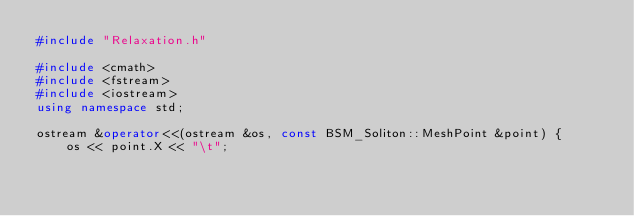Convert code to text. <code><loc_0><loc_0><loc_500><loc_500><_C++_>#include "Relaxation.h"

#include <cmath>
#include <fstream>
#include <iostream>
using namespace std;

ostream &operator<<(ostream &os, const BSM_Soliton::MeshPoint &point) {
    os << point.X << "\t";</code> 